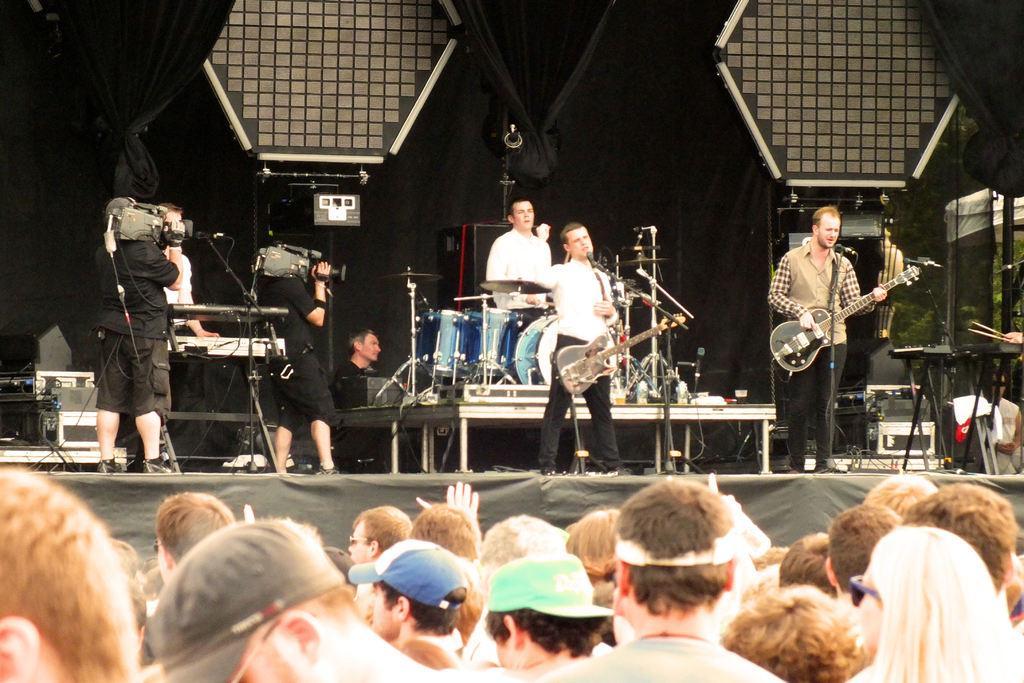Could you give a brief overview of what you see in this image? This image might be clicked in a musical concert. There are so many musical instruments. Two are playing guitar, one is playing keyboard, one is playing drums. There are two persons, who is covering video on the left side. There are so many people at the bottom. 